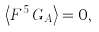<formula> <loc_0><loc_0><loc_500><loc_500>\left \langle F ^ { 5 } \, G _ { A } \right \rangle = 0 ,</formula> 